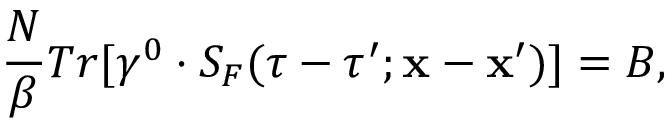<formula> <loc_0><loc_0><loc_500><loc_500>\frac { N } { \beta } T r [ \gamma ^ { 0 } \cdot S _ { F } ( \tau - \tau ^ { \prime } ; { x } - { x } ^ { \prime } ) ] = B ,</formula> 